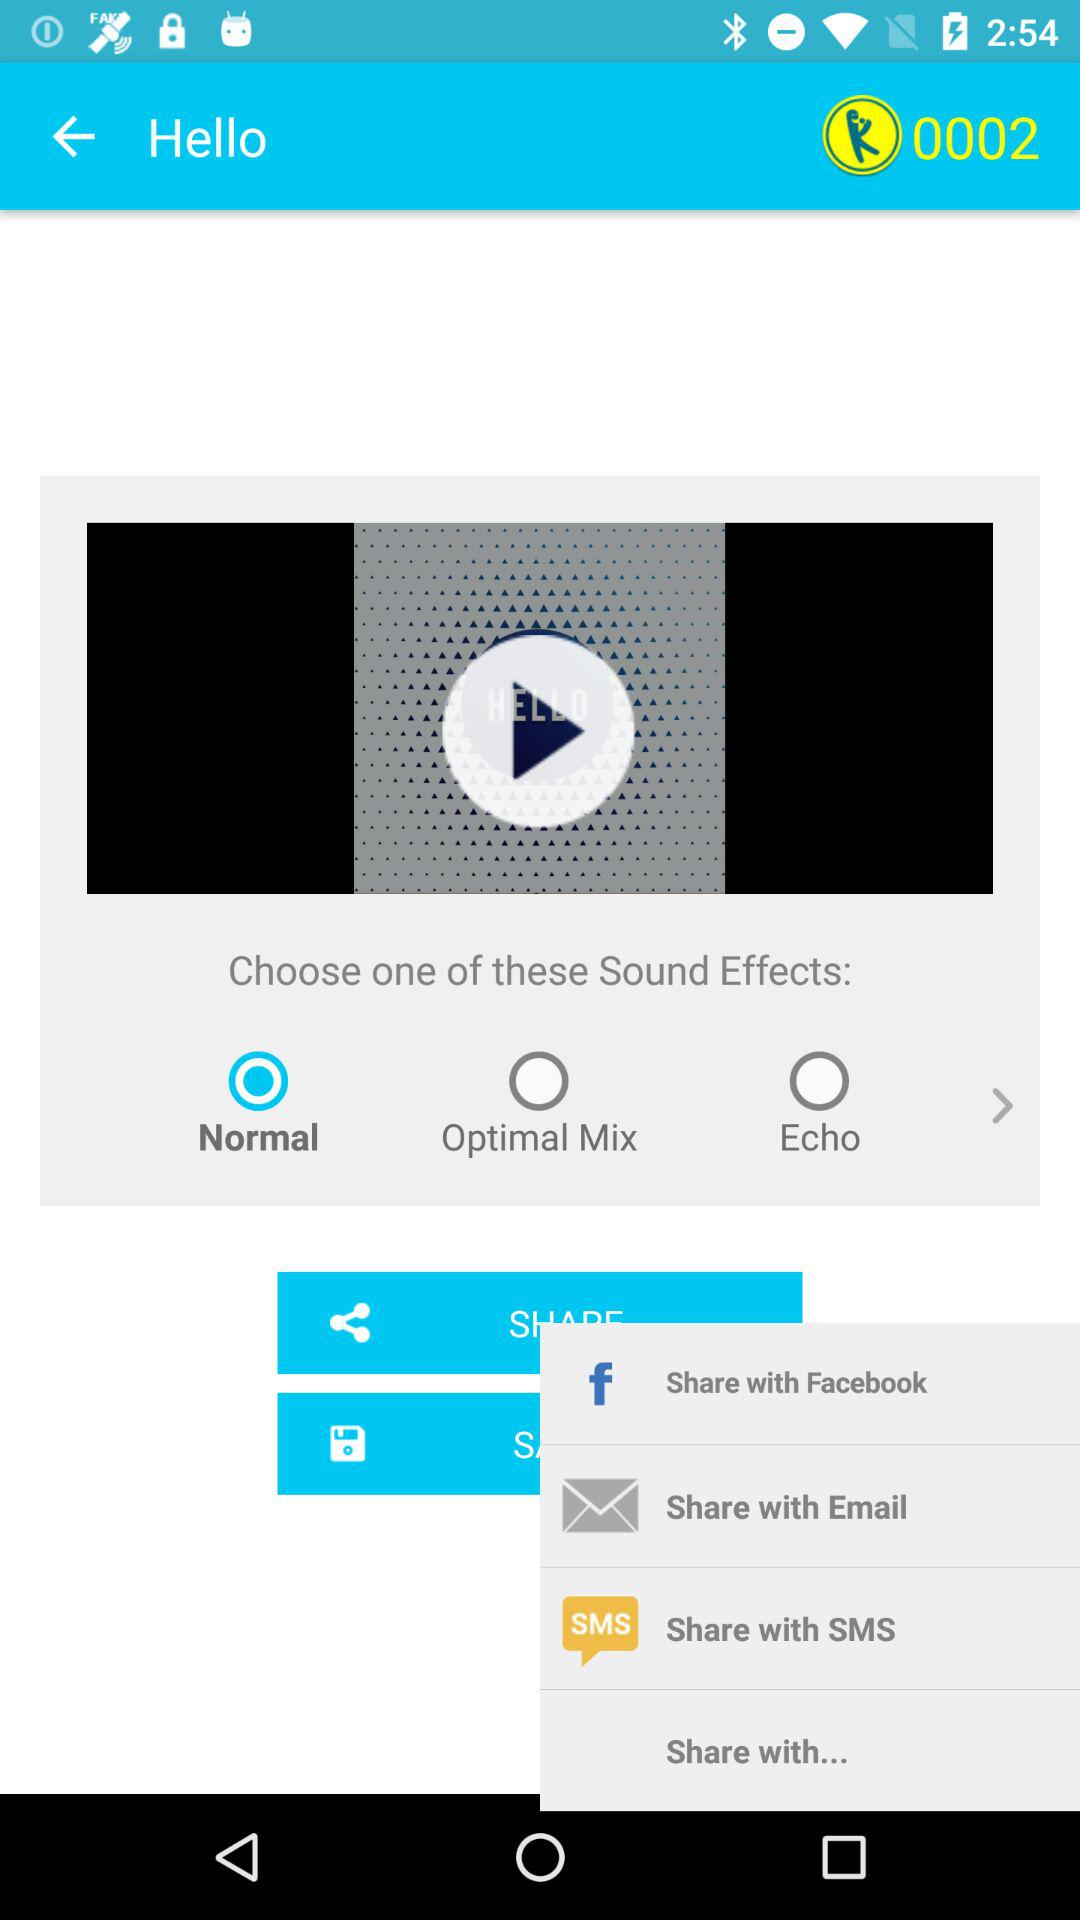What radio button is selected for the sound effect? The selected radio button is "Normal". 